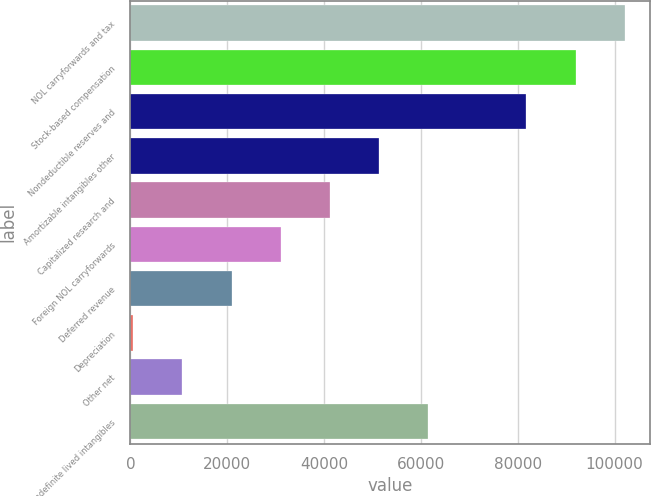<chart> <loc_0><loc_0><loc_500><loc_500><bar_chart><fcel>NOL carryforwards and tax<fcel>Stock-based compensation<fcel>Nondeductible reserves and<fcel>Amortizable intangibles other<fcel>Capitalized research and<fcel>Foreign NOL carryforwards<fcel>Deferred revenue<fcel>Depreciation<fcel>Other net<fcel>Indefinite lived intangibles<nl><fcel>102093<fcel>91939.8<fcel>81786.6<fcel>51327<fcel>41173.8<fcel>31020.6<fcel>20867.4<fcel>561<fcel>10714.2<fcel>61480.2<nl></chart> 